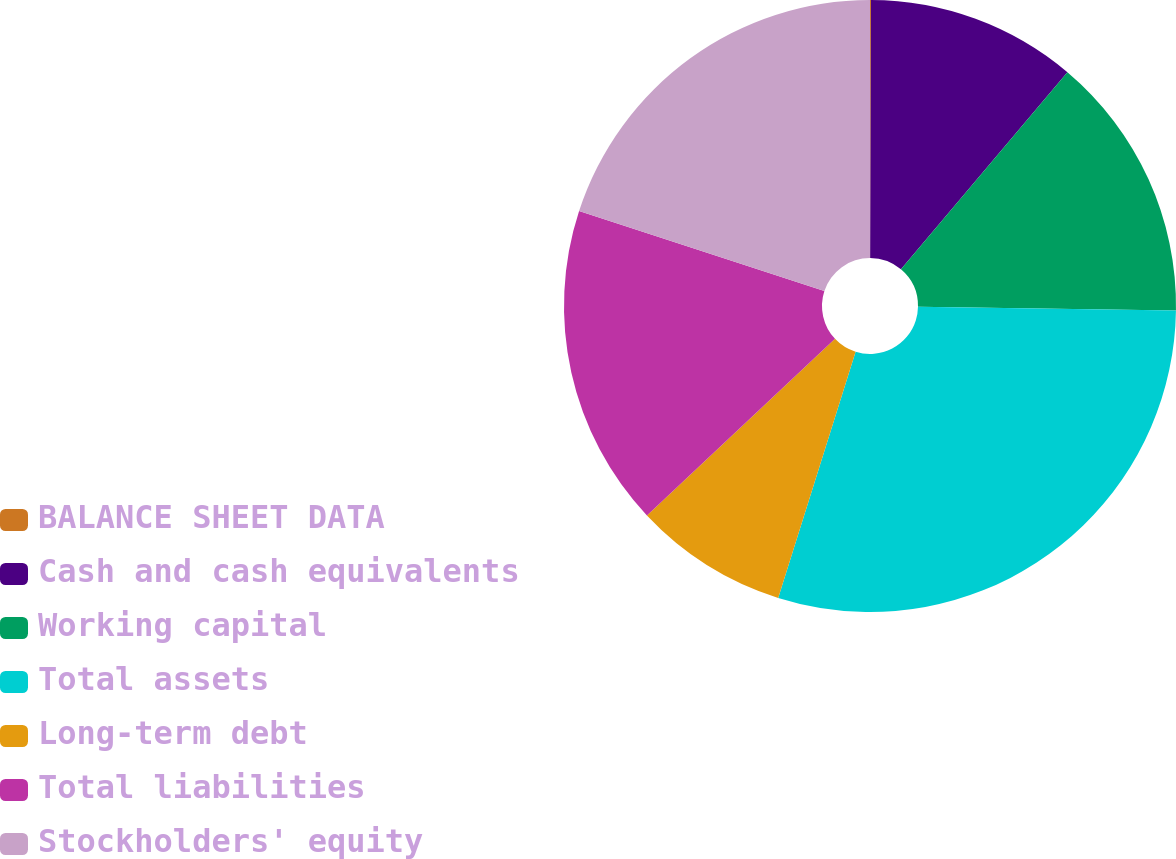<chart> <loc_0><loc_0><loc_500><loc_500><pie_chart><fcel>BALANCE SHEET DATA<fcel>Cash and cash equivalents<fcel>Working capital<fcel>Total assets<fcel>Long-term debt<fcel>Total liabilities<fcel>Stockholders' equity<nl><fcel>0.05%<fcel>11.11%<fcel>14.07%<fcel>29.62%<fcel>8.15%<fcel>17.02%<fcel>19.98%<nl></chart> 